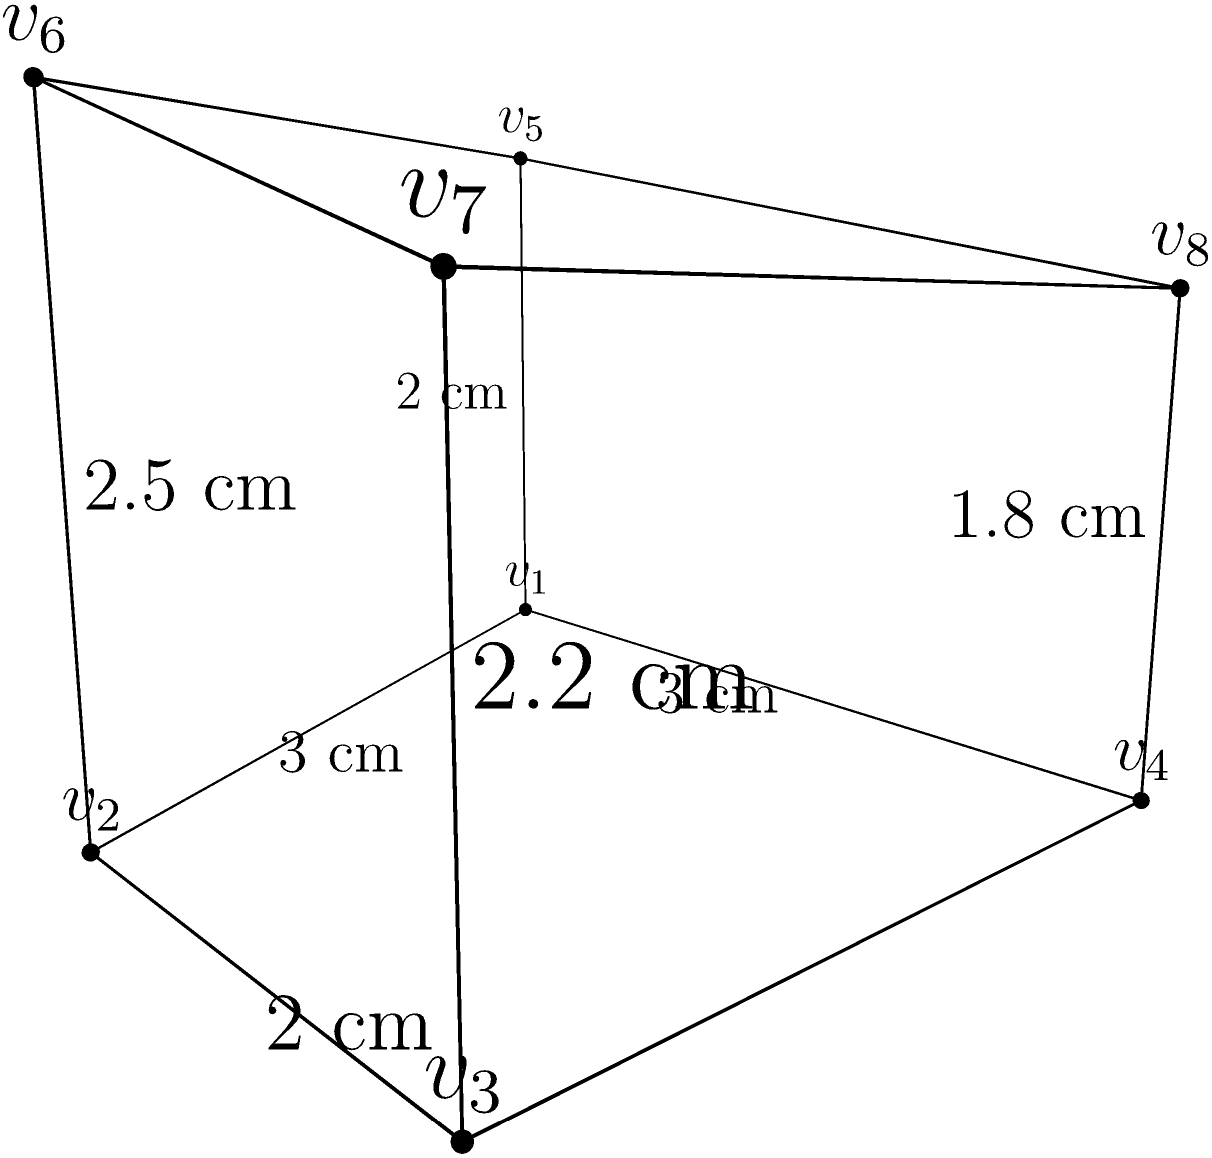An irregularly shaped artifact has been discovered at an archaeological site in Uzbekistan. The artifact resembles a prism with varying heights at each vertex. The base of the artifact is a quadrilateral with sides measuring 3 cm, 2 cm, 3 cm, and approximately 3.61 cm. The heights at each vertex are 2 cm, 2.5 cm, 2.2 cm, and 1.8 cm, respectively. Calculate the volume of this artifact to the nearest cubic centimeter. To calculate the volume of this irregular prism, we'll use the following steps:

1) First, we need to find the area of the base. The base is an irregular quadrilateral, so we'll divide it into two triangles and sum their areas.

2) For the first triangle (v1, v2, v3):
   Area = $\frac{1}{2} \times base \times height$
   Base = 3 cm, Height = 2 cm
   Area1 = $\frac{1}{2} \times 3 \times 2 = 3$ cm²

3) For the second triangle (v1, v3, v4):
   We can use Heron's formula: $A = \sqrt{s(s-a)(s-b)(s-c)}$
   where $s = \frac{a+b+c}{2}$ (half-perimeter)
   a ≈ 3.61 cm (diagonal), b = 3 cm, c = 2 cm
   $s = \frac{3.61 + 3 + 2}{2} = 4.305$ cm
   Area2 = $\sqrt{4.305(4.305-3.61)(4.305-3)(4.305-2)} \approx 2.95$ cm²

4) Total base area = Area1 + Area2 = 3 + 2.95 = 5.95 cm²

5) For the volume, we'll use the average height method:
   Average height = $\frac{2 + 2.5 + 2.2 + 1.8}{4} = 2.125$ cm

6) Volume = Base area × Average height
   Volume = 5.95 × 2.125 = 12.64375 cm³

7) Rounding to the nearest cubic centimeter:
   Volume ≈ 13 cm³
Answer: 13 cm³ 